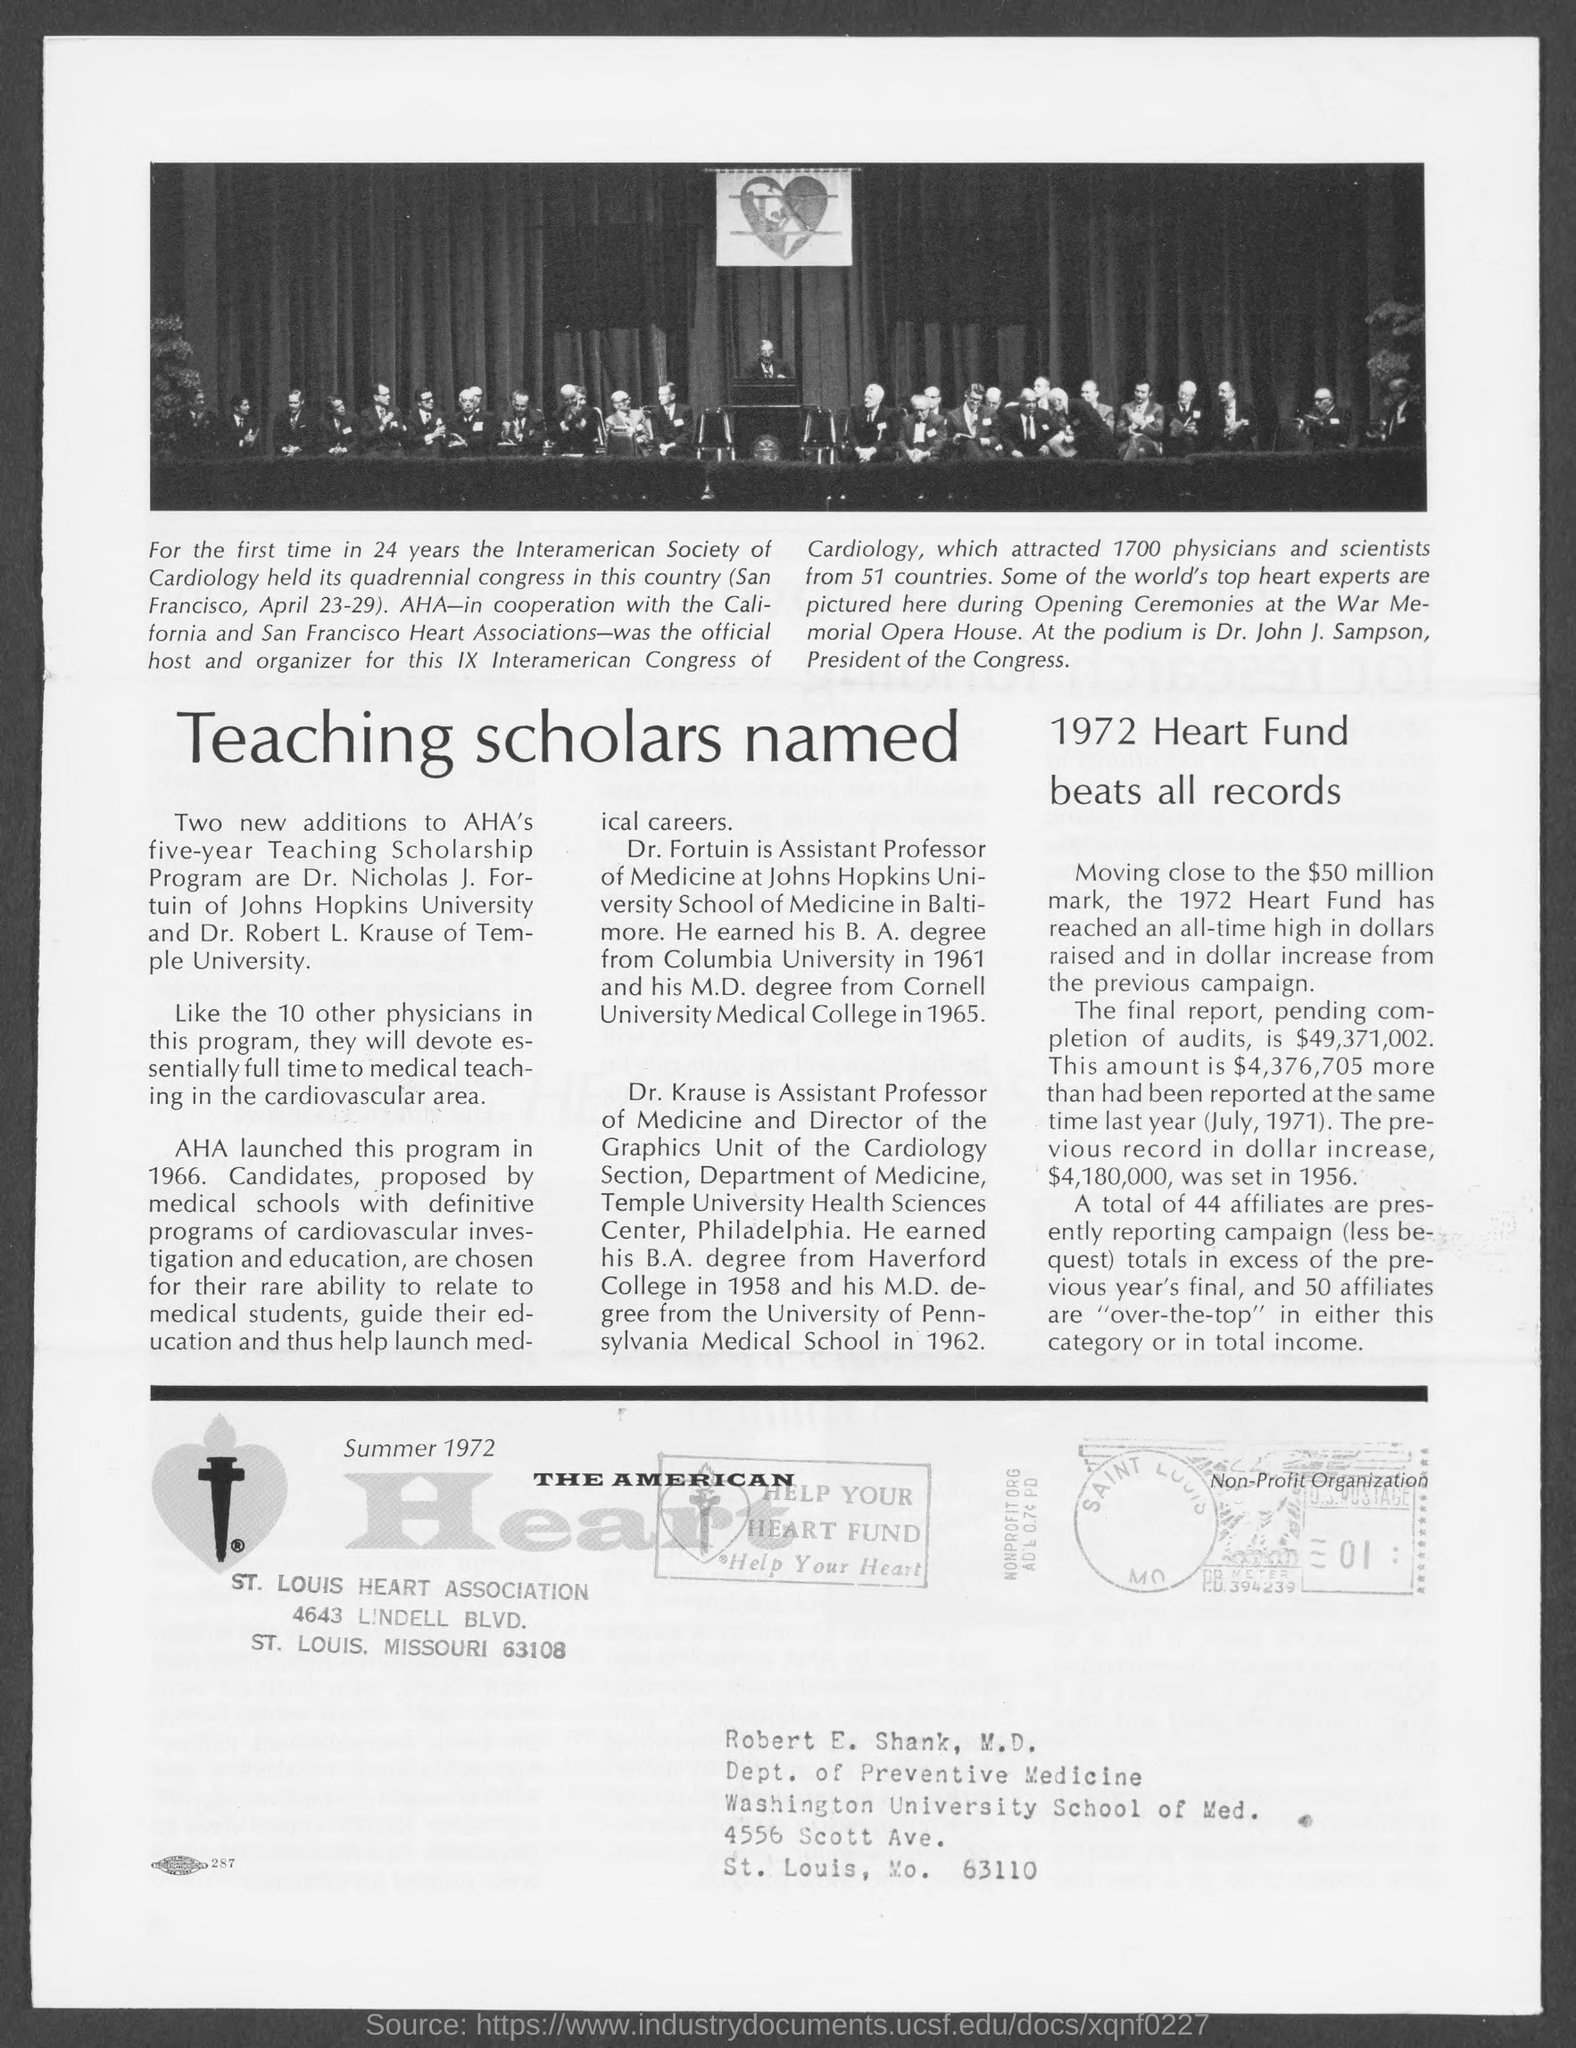Draw attention to some important aspects in this diagram. The president of the IX Interamerican Congress of Cardiology is Dr. John J. Sampson. The number mentioned in the bottom seal of the box is 01. The main heading of this feature is "Teaching Scholars Named. 